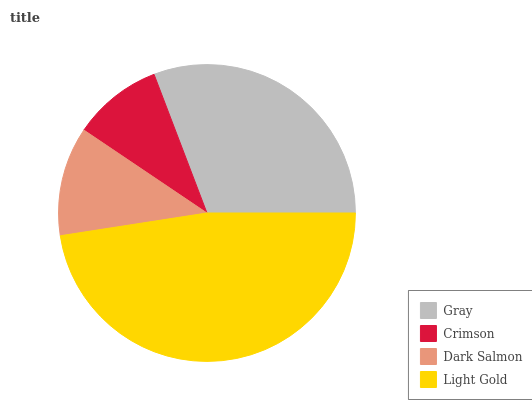Is Crimson the minimum?
Answer yes or no. Yes. Is Light Gold the maximum?
Answer yes or no. Yes. Is Dark Salmon the minimum?
Answer yes or no. No. Is Dark Salmon the maximum?
Answer yes or no. No. Is Dark Salmon greater than Crimson?
Answer yes or no. Yes. Is Crimson less than Dark Salmon?
Answer yes or no. Yes. Is Crimson greater than Dark Salmon?
Answer yes or no. No. Is Dark Salmon less than Crimson?
Answer yes or no. No. Is Gray the high median?
Answer yes or no. Yes. Is Dark Salmon the low median?
Answer yes or no. Yes. Is Light Gold the high median?
Answer yes or no. No. Is Crimson the low median?
Answer yes or no. No. 